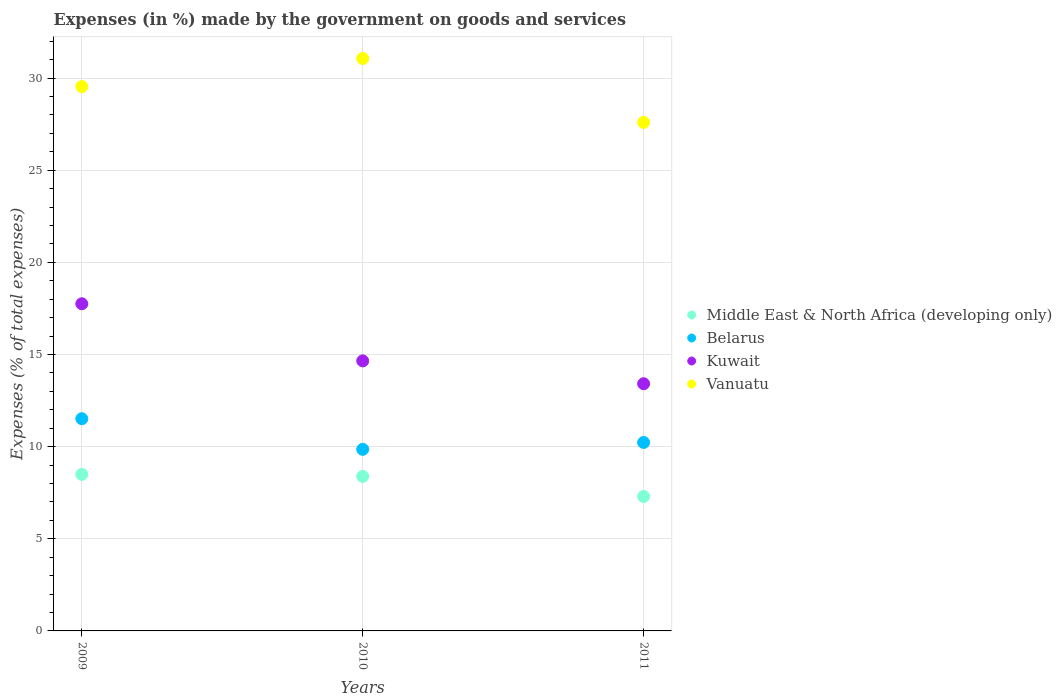What is the percentage of expenses made by the government on goods and services in Middle East & North Africa (developing only) in 2011?
Ensure brevity in your answer.  7.3. Across all years, what is the maximum percentage of expenses made by the government on goods and services in Middle East & North Africa (developing only)?
Give a very brief answer. 8.49. Across all years, what is the minimum percentage of expenses made by the government on goods and services in Kuwait?
Your answer should be very brief. 13.41. In which year was the percentage of expenses made by the government on goods and services in Belarus maximum?
Offer a terse response. 2009. What is the total percentage of expenses made by the government on goods and services in Kuwait in the graph?
Offer a terse response. 45.82. What is the difference between the percentage of expenses made by the government on goods and services in Middle East & North Africa (developing only) in 2009 and that in 2010?
Make the answer very short. 0.11. What is the difference between the percentage of expenses made by the government on goods and services in Vanuatu in 2009 and the percentage of expenses made by the government on goods and services in Kuwait in 2010?
Offer a terse response. 14.88. What is the average percentage of expenses made by the government on goods and services in Kuwait per year?
Offer a very short reply. 15.27. In the year 2010, what is the difference between the percentage of expenses made by the government on goods and services in Kuwait and percentage of expenses made by the government on goods and services in Vanuatu?
Keep it short and to the point. -16.41. What is the ratio of the percentage of expenses made by the government on goods and services in Kuwait in 2009 to that in 2010?
Give a very brief answer. 1.21. Is the percentage of expenses made by the government on goods and services in Middle East & North Africa (developing only) in 2009 less than that in 2010?
Provide a succinct answer. No. What is the difference between the highest and the second highest percentage of expenses made by the government on goods and services in Belarus?
Your response must be concise. 1.29. What is the difference between the highest and the lowest percentage of expenses made by the government on goods and services in Kuwait?
Offer a terse response. 4.34. In how many years, is the percentage of expenses made by the government on goods and services in Vanuatu greater than the average percentage of expenses made by the government on goods and services in Vanuatu taken over all years?
Keep it short and to the point. 2. Is the sum of the percentage of expenses made by the government on goods and services in Vanuatu in 2009 and 2011 greater than the maximum percentage of expenses made by the government on goods and services in Belarus across all years?
Offer a very short reply. Yes. Is the percentage of expenses made by the government on goods and services in Belarus strictly greater than the percentage of expenses made by the government on goods and services in Middle East & North Africa (developing only) over the years?
Provide a short and direct response. Yes. Is the percentage of expenses made by the government on goods and services in Middle East & North Africa (developing only) strictly less than the percentage of expenses made by the government on goods and services in Vanuatu over the years?
Keep it short and to the point. Yes. How many years are there in the graph?
Ensure brevity in your answer.  3. Are the values on the major ticks of Y-axis written in scientific E-notation?
Your answer should be very brief. No. Where does the legend appear in the graph?
Provide a succinct answer. Center right. How many legend labels are there?
Offer a very short reply. 4. What is the title of the graph?
Provide a short and direct response. Expenses (in %) made by the government on goods and services. What is the label or title of the Y-axis?
Offer a terse response. Expenses (% of total expenses). What is the Expenses (% of total expenses) of Middle East & North Africa (developing only) in 2009?
Your answer should be compact. 8.49. What is the Expenses (% of total expenses) of Belarus in 2009?
Give a very brief answer. 11.51. What is the Expenses (% of total expenses) in Kuwait in 2009?
Offer a very short reply. 17.75. What is the Expenses (% of total expenses) in Vanuatu in 2009?
Provide a succinct answer. 29.54. What is the Expenses (% of total expenses) of Middle East & North Africa (developing only) in 2010?
Provide a succinct answer. 8.38. What is the Expenses (% of total expenses) in Belarus in 2010?
Your response must be concise. 9.85. What is the Expenses (% of total expenses) in Kuwait in 2010?
Keep it short and to the point. 14.65. What is the Expenses (% of total expenses) in Vanuatu in 2010?
Give a very brief answer. 31.06. What is the Expenses (% of total expenses) in Middle East & North Africa (developing only) in 2011?
Provide a short and direct response. 7.3. What is the Expenses (% of total expenses) in Belarus in 2011?
Provide a succinct answer. 10.23. What is the Expenses (% of total expenses) in Kuwait in 2011?
Keep it short and to the point. 13.41. What is the Expenses (% of total expenses) of Vanuatu in 2011?
Offer a very short reply. 27.6. Across all years, what is the maximum Expenses (% of total expenses) of Middle East & North Africa (developing only)?
Provide a short and direct response. 8.49. Across all years, what is the maximum Expenses (% of total expenses) of Belarus?
Offer a terse response. 11.51. Across all years, what is the maximum Expenses (% of total expenses) of Kuwait?
Offer a terse response. 17.75. Across all years, what is the maximum Expenses (% of total expenses) in Vanuatu?
Keep it short and to the point. 31.06. Across all years, what is the minimum Expenses (% of total expenses) of Middle East & North Africa (developing only)?
Your answer should be compact. 7.3. Across all years, what is the minimum Expenses (% of total expenses) of Belarus?
Offer a terse response. 9.85. Across all years, what is the minimum Expenses (% of total expenses) in Kuwait?
Provide a short and direct response. 13.41. Across all years, what is the minimum Expenses (% of total expenses) in Vanuatu?
Your answer should be very brief. 27.6. What is the total Expenses (% of total expenses) of Middle East & North Africa (developing only) in the graph?
Your response must be concise. 24.17. What is the total Expenses (% of total expenses) of Belarus in the graph?
Your answer should be very brief. 31.6. What is the total Expenses (% of total expenses) in Kuwait in the graph?
Your answer should be compact. 45.82. What is the total Expenses (% of total expenses) in Vanuatu in the graph?
Keep it short and to the point. 88.19. What is the difference between the Expenses (% of total expenses) in Middle East & North Africa (developing only) in 2009 and that in 2010?
Your response must be concise. 0.11. What is the difference between the Expenses (% of total expenses) in Belarus in 2009 and that in 2010?
Provide a succinct answer. 1.66. What is the difference between the Expenses (% of total expenses) of Kuwait in 2009 and that in 2010?
Give a very brief answer. 3.1. What is the difference between the Expenses (% of total expenses) in Vanuatu in 2009 and that in 2010?
Make the answer very short. -1.53. What is the difference between the Expenses (% of total expenses) in Middle East & North Africa (developing only) in 2009 and that in 2011?
Offer a terse response. 1.2. What is the difference between the Expenses (% of total expenses) in Belarus in 2009 and that in 2011?
Keep it short and to the point. 1.29. What is the difference between the Expenses (% of total expenses) of Kuwait in 2009 and that in 2011?
Provide a short and direct response. 4.34. What is the difference between the Expenses (% of total expenses) of Vanuatu in 2009 and that in 2011?
Make the answer very short. 1.94. What is the difference between the Expenses (% of total expenses) in Middle East & North Africa (developing only) in 2010 and that in 2011?
Provide a succinct answer. 1.09. What is the difference between the Expenses (% of total expenses) of Belarus in 2010 and that in 2011?
Ensure brevity in your answer.  -0.37. What is the difference between the Expenses (% of total expenses) in Kuwait in 2010 and that in 2011?
Provide a short and direct response. 1.24. What is the difference between the Expenses (% of total expenses) of Vanuatu in 2010 and that in 2011?
Provide a succinct answer. 3.47. What is the difference between the Expenses (% of total expenses) in Middle East & North Africa (developing only) in 2009 and the Expenses (% of total expenses) in Belarus in 2010?
Your answer should be compact. -1.36. What is the difference between the Expenses (% of total expenses) of Middle East & North Africa (developing only) in 2009 and the Expenses (% of total expenses) of Kuwait in 2010?
Keep it short and to the point. -6.16. What is the difference between the Expenses (% of total expenses) of Middle East & North Africa (developing only) in 2009 and the Expenses (% of total expenses) of Vanuatu in 2010?
Your answer should be compact. -22.57. What is the difference between the Expenses (% of total expenses) in Belarus in 2009 and the Expenses (% of total expenses) in Kuwait in 2010?
Ensure brevity in your answer.  -3.14. What is the difference between the Expenses (% of total expenses) in Belarus in 2009 and the Expenses (% of total expenses) in Vanuatu in 2010?
Offer a terse response. -19.55. What is the difference between the Expenses (% of total expenses) in Kuwait in 2009 and the Expenses (% of total expenses) in Vanuatu in 2010?
Your response must be concise. -13.31. What is the difference between the Expenses (% of total expenses) in Middle East & North Africa (developing only) in 2009 and the Expenses (% of total expenses) in Belarus in 2011?
Provide a succinct answer. -1.73. What is the difference between the Expenses (% of total expenses) in Middle East & North Africa (developing only) in 2009 and the Expenses (% of total expenses) in Kuwait in 2011?
Your answer should be very brief. -4.92. What is the difference between the Expenses (% of total expenses) in Middle East & North Africa (developing only) in 2009 and the Expenses (% of total expenses) in Vanuatu in 2011?
Your answer should be compact. -19.1. What is the difference between the Expenses (% of total expenses) in Belarus in 2009 and the Expenses (% of total expenses) in Kuwait in 2011?
Provide a succinct answer. -1.9. What is the difference between the Expenses (% of total expenses) in Belarus in 2009 and the Expenses (% of total expenses) in Vanuatu in 2011?
Make the answer very short. -16.08. What is the difference between the Expenses (% of total expenses) of Kuwait in 2009 and the Expenses (% of total expenses) of Vanuatu in 2011?
Provide a short and direct response. -9.84. What is the difference between the Expenses (% of total expenses) of Middle East & North Africa (developing only) in 2010 and the Expenses (% of total expenses) of Belarus in 2011?
Your answer should be compact. -1.84. What is the difference between the Expenses (% of total expenses) of Middle East & North Africa (developing only) in 2010 and the Expenses (% of total expenses) of Kuwait in 2011?
Your answer should be very brief. -5.03. What is the difference between the Expenses (% of total expenses) of Middle East & North Africa (developing only) in 2010 and the Expenses (% of total expenses) of Vanuatu in 2011?
Your answer should be very brief. -19.21. What is the difference between the Expenses (% of total expenses) in Belarus in 2010 and the Expenses (% of total expenses) in Kuwait in 2011?
Your answer should be very brief. -3.56. What is the difference between the Expenses (% of total expenses) of Belarus in 2010 and the Expenses (% of total expenses) of Vanuatu in 2011?
Your response must be concise. -17.74. What is the difference between the Expenses (% of total expenses) of Kuwait in 2010 and the Expenses (% of total expenses) of Vanuatu in 2011?
Offer a terse response. -12.94. What is the average Expenses (% of total expenses) of Middle East & North Africa (developing only) per year?
Ensure brevity in your answer.  8.06. What is the average Expenses (% of total expenses) in Belarus per year?
Keep it short and to the point. 10.53. What is the average Expenses (% of total expenses) in Kuwait per year?
Keep it short and to the point. 15.27. What is the average Expenses (% of total expenses) in Vanuatu per year?
Ensure brevity in your answer.  29.4. In the year 2009, what is the difference between the Expenses (% of total expenses) of Middle East & North Africa (developing only) and Expenses (% of total expenses) of Belarus?
Keep it short and to the point. -3.02. In the year 2009, what is the difference between the Expenses (% of total expenses) in Middle East & North Africa (developing only) and Expenses (% of total expenses) in Kuwait?
Offer a terse response. -9.26. In the year 2009, what is the difference between the Expenses (% of total expenses) of Middle East & North Africa (developing only) and Expenses (% of total expenses) of Vanuatu?
Ensure brevity in your answer.  -21.04. In the year 2009, what is the difference between the Expenses (% of total expenses) of Belarus and Expenses (% of total expenses) of Kuwait?
Offer a terse response. -6.24. In the year 2009, what is the difference between the Expenses (% of total expenses) in Belarus and Expenses (% of total expenses) in Vanuatu?
Provide a succinct answer. -18.02. In the year 2009, what is the difference between the Expenses (% of total expenses) in Kuwait and Expenses (% of total expenses) in Vanuatu?
Your answer should be very brief. -11.78. In the year 2010, what is the difference between the Expenses (% of total expenses) in Middle East & North Africa (developing only) and Expenses (% of total expenses) in Belarus?
Keep it short and to the point. -1.47. In the year 2010, what is the difference between the Expenses (% of total expenses) of Middle East & North Africa (developing only) and Expenses (% of total expenses) of Kuwait?
Ensure brevity in your answer.  -6.27. In the year 2010, what is the difference between the Expenses (% of total expenses) in Middle East & North Africa (developing only) and Expenses (% of total expenses) in Vanuatu?
Your answer should be compact. -22.68. In the year 2010, what is the difference between the Expenses (% of total expenses) in Belarus and Expenses (% of total expenses) in Kuwait?
Offer a terse response. -4.8. In the year 2010, what is the difference between the Expenses (% of total expenses) of Belarus and Expenses (% of total expenses) of Vanuatu?
Make the answer very short. -21.21. In the year 2010, what is the difference between the Expenses (% of total expenses) in Kuwait and Expenses (% of total expenses) in Vanuatu?
Make the answer very short. -16.41. In the year 2011, what is the difference between the Expenses (% of total expenses) of Middle East & North Africa (developing only) and Expenses (% of total expenses) of Belarus?
Give a very brief answer. -2.93. In the year 2011, what is the difference between the Expenses (% of total expenses) of Middle East & North Africa (developing only) and Expenses (% of total expenses) of Kuwait?
Your response must be concise. -6.12. In the year 2011, what is the difference between the Expenses (% of total expenses) of Middle East & North Africa (developing only) and Expenses (% of total expenses) of Vanuatu?
Give a very brief answer. -20.3. In the year 2011, what is the difference between the Expenses (% of total expenses) in Belarus and Expenses (% of total expenses) in Kuwait?
Offer a very short reply. -3.19. In the year 2011, what is the difference between the Expenses (% of total expenses) of Belarus and Expenses (% of total expenses) of Vanuatu?
Your answer should be very brief. -17.37. In the year 2011, what is the difference between the Expenses (% of total expenses) in Kuwait and Expenses (% of total expenses) in Vanuatu?
Ensure brevity in your answer.  -14.18. What is the ratio of the Expenses (% of total expenses) in Middle East & North Africa (developing only) in 2009 to that in 2010?
Keep it short and to the point. 1.01. What is the ratio of the Expenses (% of total expenses) in Belarus in 2009 to that in 2010?
Provide a succinct answer. 1.17. What is the ratio of the Expenses (% of total expenses) in Kuwait in 2009 to that in 2010?
Provide a succinct answer. 1.21. What is the ratio of the Expenses (% of total expenses) in Vanuatu in 2009 to that in 2010?
Keep it short and to the point. 0.95. What is the ratio of the Expenses (% of total expenses) in Middle East & North Africa (developing only) in 2009 to that in 2011?
Your response must be concise. 1.16. What is the ratio of the Expenses (% of total expenses) of Belarus in 2009 to that in 2011?
Offer a very short reply. 1.13. What is the ratio of the Expenses (% of total expenses) in Kuwait in 2009 to that in 2011?
Offer a terse response. 1.32. What is the ratio of the Expenses (% of total expenses) in Vanuatu in 2009 to that in 2011?
Provide a short and direct response. 1.07. What is the ratio of the Expenses (% of total expenses) of Middle East & North Africa (developing only) in 2010 to that in 2011?
Ensure brevity in your answer.  1.15. What is the ratio of the Expenses (% of total expenses) in Belarus in 2010 to that in 2011?
Give a very brief answer. 0.96. What is the ratio of the Expenses (% of total expenses) in Kuwait in 2010 to that in 2011?
Your response must be concise. 1.09. What is the ratio of the Expenses (% of total expenses) of Vanuatu in 2010 to that in 2011?
Offer a very short reply. 1.13. What is the difference between the highest and the second highest Expenses (% of total expenses) of Middle East & North Africa (developing only)?
Offer a terse response. 0.11. What is the difference between the highest and the second highest Expenses (% of total expenses) of Belarus?
Offer a very short reply. 1.29. What is the difference between the highest and the second highest Expenses (% of total expenses) in Kuwait?
Your response must be concise. 3.1. What is the difference between the highest and the second highest Expenses (% of total expenses) of Vanuatu?
Your answer should be compact. 1.53. What is the difference between the highest and the lowest Expenses (% of total expenses) in Middle East & North Africa (developing only)?
Your response must be concise. 1.2. What is the difference between the highest and the lowest Expenses (% of total expenses) in Belarus?
Offer a terse response. 1.66. What is the difference between the highest and the lowest Expenses (% of total expenses) of Kuwait?
Keep it short and to the point. 4.34. What is the difference between the highest and the lowest Expenses (% of total expenses) of Vanuatu?
Provide a short and direct response. 3.47. 